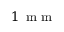Convert formula to latex. <formula><loc_0><loc_0><loc_500><loc_500>1 \, m m</formula> 